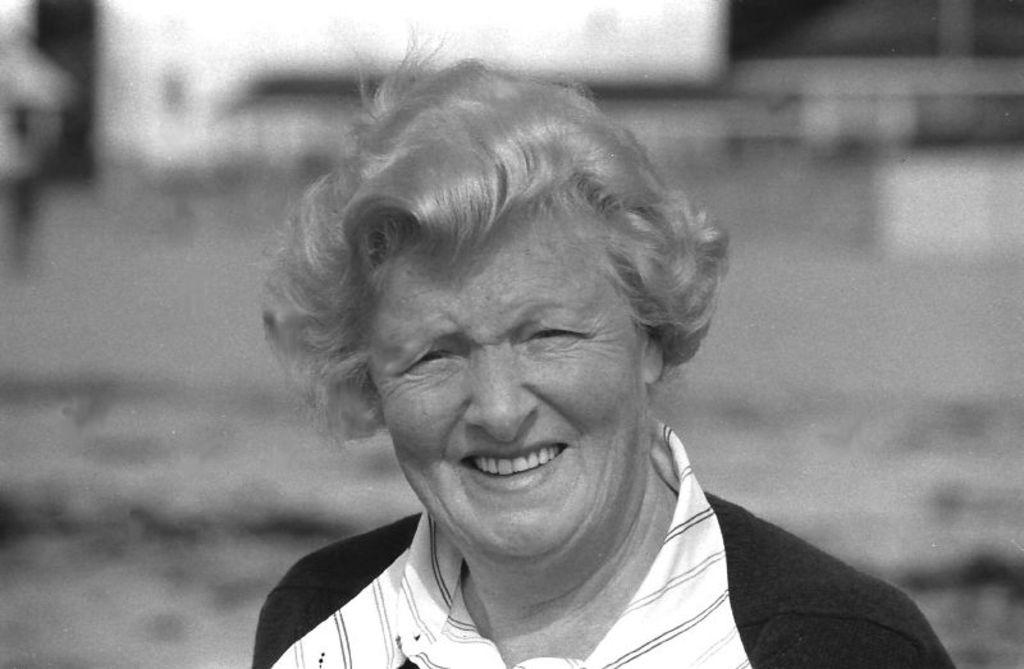Who is present in the image? There is a woman in the image. What is the woman's facial expression? The woman is smiling. Can you describe the background of the image? The background of the image is blurred. What type of collar can be seen on the flock of birds in the image? There are no birds or collars present in the image; it features a woman with a blurred background. 